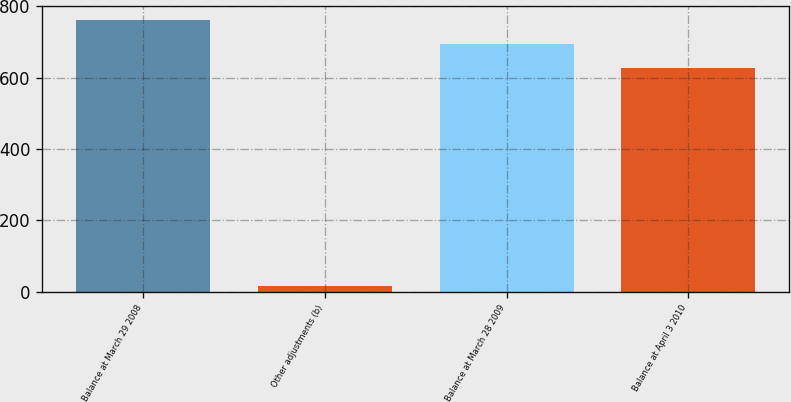Convert chart. <chart><loc_0><loc_0><loc_500><loc_500><bar_chart><fcel>Balance at March 29 2008<fcel>Other adjustments (b)<fcel>Balance at March 28 2009<fcel>Balance at April 3 2010<nl><fcel>762.16<fcel>15.5<fcel>695.23<fcel>628.3<nl></chart> 